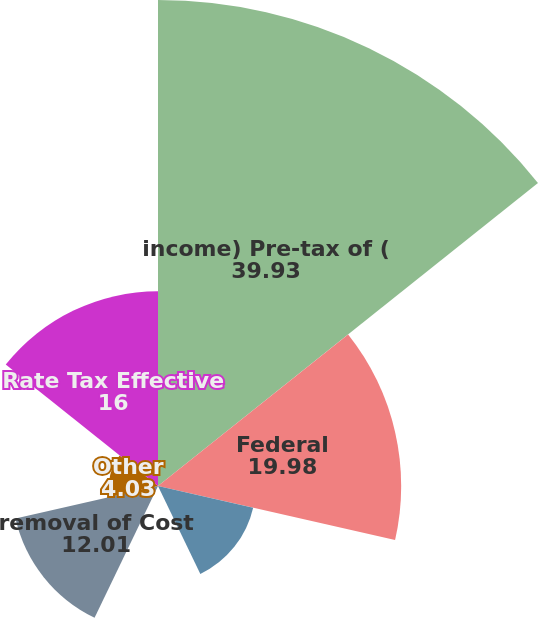Convert chart. <chart><loc_0><loc_0><loc_500><loc_500><pie_chart><fcel>income) Pre-tax of (<fcel>Federal<fcel>tax income State<fcel>ferences d related<fcel>removal of Cost<fcel>Other<fcel>Rate Tax Effective<nl><fcel>39.93%<fcel>19.98%<fcel>8.02%<fcel>0.04%<fcel>12.01%<fcel>4.03%<fcel>16.0%<nl></chart> 